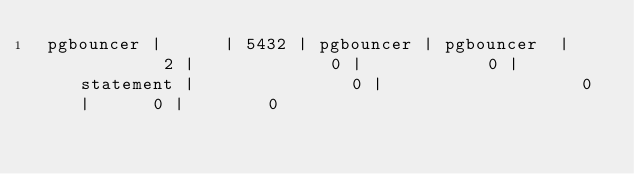<code> <loc_0><loc_0><loc_500><loc_500><_SQL_> pgbouncer |      | 5432 | pgbouncer | pgbouncer  |         2 |             0 |            0 | statement |               0 |                   0 |      0 |        0

</code> 